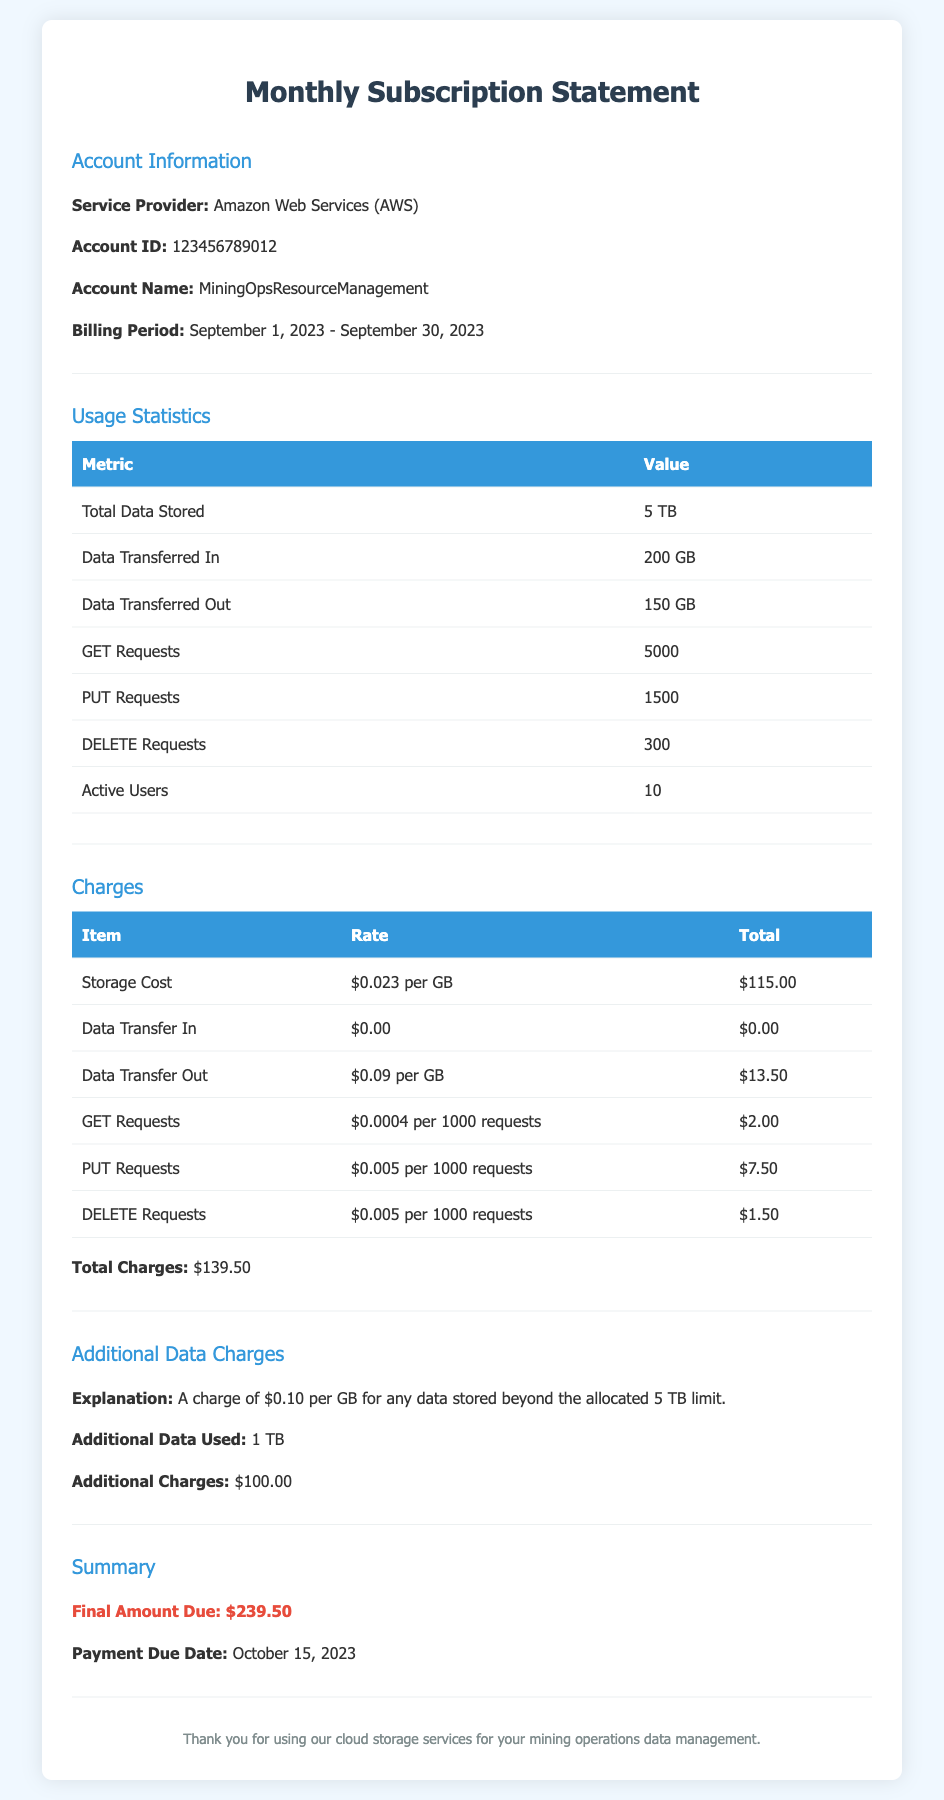What is the service provider? The service provider is clearly stated in the document under Account Information.
Answer: Amazon Web Services (AWS) What is the billing period? The document specifies the billing period for which the charges apply.
Answer: September 1, 2023 - September 30, 2023 How much data is stored in total? The total data stored is listed under Usage Statistics.
Answer: 5 TB What is the total amount due? The final amount due is highlighted in the Summary section of the document.
Answer: $239.50 How many active users are there? The number of active users is provided in the Usage Statistics table.
Answer: 10 What is the charge for additional data used? The explanation for additional data charges is found in the Additional Data Charges section.
Answer: $100.00 What is the rate for Data Transfer Out? The rate for Data Transfer Out is mentioned in the Charges section of the document.
Answer: $0.09 per GB How much is charged for GET Requests? The cost for GET Requests is clearly detailed in the Charges table.
Answer: $2.00 What is the payment due date? The payment due date is mentioned in the Summary section of the document.
Answer: October 15, 2023 